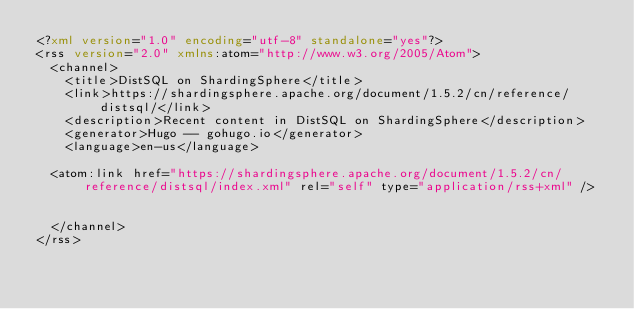<code> <loc_0><loc_0><loc_500><loc_500><_XML_><?xml version="1.0" encoding="utf-8" standalone="yes"?>
<rss version="2.0" xmlns:atom="http://www.w3.org/2005/Atom">
  <channel>
    <title>DistSQL on ShardingSphere</title>
    <link>https://shardingsphere.apache.org/document/1.5.2/cn/reference/distsql/</link>
    <description>Recent content in DistSQL on ShardingSphere</description>
    <generator>Hugo -- gohugo.io</generator>
    <language>en-us</language>
    
	<atom:link href="https://shardingsphere.apache.org/document/1.5.2/cn/reference/distsql/index.xml" rel="self" type="application/rss+xml" />
    
    
  </channel>
</rss></code> 